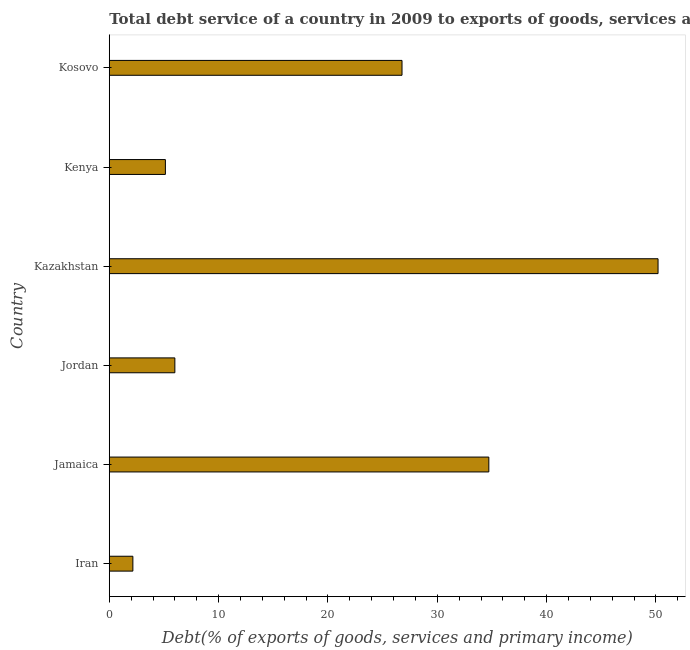Does the graph contain grids?
Offer a terse response. No. What is the title of the graph?
Offer a terse response. Total debt service of a country in 2009 to exports of goods, services and primary income. What is the label or title of the X-axis?
Offer a very short reply. Debt(% of exports of goods, services and primary income). What is the total debt service in Kosovo?
Offer a very short reply. 26.78. Across all countries, what is the maximum total debt service?
Offer a very short reply. 50.19. Across all countries, what is the minimum total debt service?
Your response must be concise. 2.16. In which country was the total debt service maximum?
Offer a very short reply. Kazakhstan. In which country was the total debt service minimum?
Offer a terse response. Iran. What is the sum of the total debt service?
Your response must be concise. 124.98. What is the difference between the total debt service in Kazakhstan and Kenya?
Your answer should be very brief. 45.06. What is the average total debt service per country?
Ensure brevity in your answer.  20.83. What is the median total debt service?
Ensure brevity in your answer.  16.39. What is the ratio of the total debt service in Jordan to that in Kosovo?
Your answer should be compact. 0.22. Is the difference between the total debt service in Jordan and Kosovo greater than the difference between any two countries?
Ensure brevity in your answer.  No. What is the difference between the highest and the second highest total debt service?
Your response must be concise. 15.48. What is the difference between the highest and the lowest total debt service?
Provide a succinct answer. 48.04. How many bars are there?
Your answer should be compact. 6. How many countries are there in the graph?
Ensure brevity in your answer.  6. What is the difference between two consecutive major ticks on the X-axis?
Your response must be concise. 10. Are the values on the major ticks of X-axis written in scientific E-notation?
Make the answer very short. No. What is the Debt(% of exports of goods, services and primary income) in Iran?
Offer a very short reply. 2.16. What is the Debt(% of exports of goods, services and primary income) of Jamaica?
Give a very brief answer. 34.72. What is the Debt(% of exports of goods, services and primary income) of Jordan?
Keep it short and to the point. 6. What is the Debt(% of exports of goods, services and primary income) of Kazakhstan?
Ensure brevity in your answer.  50.19. What is the Debt(% of exports of goods, services and primary income) of Kenya?
Offer a terse response. 5.13. What is the Debt(% of exports of goods, services and primary income) of Kosovo?
Your answer should be very brief. 26.78. What is the difference between the Debt(% of exports of goods, services and primary income) in Iran and Jamaica?
Your answer should be very brief. -32.56. What is the difference between the Debt(% of exports of goods, services and primary income) in Iran and Jordan?
Your answer should be very brief. -3.84. What is the difference between the Debt(% of exports of goods, services and primary income) in Iran and Kazakhstan?
Offer a very short reply. -48.04. What is the difference between the Debt(% of exports of goods, services and primary income) in Iran and Kenya?
Make the answer very short. -2.97. What is the difference between the Debt(% of exports of goods, services and primary income) in Iran and Kosovo?
Offer a very short reply. -24.62. What is the difference between the Debt(% of exports of goods, services and primary income) in Jamaica and Jordan?
Make the answer very short. 28.72. What is the difference between the Debt(% of exports of goods, services and primary income) in Jamaica and Kazakhstan?
Offer a terse response. -15.48. What is the difference between the Debt(% of exports of goods, services and primary income) in Jamaica and Kenya?
Provide a short and direct response. 29.58. What is the difference between the Debt(% of exports of goods, services and primary income) in Jamaica and Kosovo?
Provide a short and direct response. 7.94. What is the difference between the Debt(% of exports of goods, services and primary income) in Jordan and Kazakhstan?
Keep it short and to the point. -44.2. What is the difference between the Debt(% of exports of goods, services and primary income) in Jordan and Kenya?
Give a very brief answer. 0.87. What is the difference between the Debt(% of exports of goods, services and primary income) in Jordan and Kosovo?
Give a very brief answer. -20.78. What is the difference between the Debt(% of exports of goods, services and primary income) in Kazakhstan and Kenya?
Offer a very short reply. 45.06. What is the difference between the Debt(% of exports of goods, services and primary income) in Kazakhstan and Kosovo?
Your response must be concise. 23.42. What is the difference between the Debt(% of exports of goods, services and primary income) in Kenya and Kosovo?
Offer a very short reply. -21.64. What is the ratio of the Debt(% of exports of goods, services and primary income) in Iran to that in Jamaica?
Keep it short and to the point. 0.06. What is the ratio of the Debt(% of exports of goods, services and primary income) in Iran to that in Jordan?
Your response must be concise. 0.36. What is the ratio of the Debt(% of exports of goods, services and primary income) in Iran to that in Kazakhstan?
Provide a succinct answer. 0.04. What is the ratio of the Debt(% of exports of goods, services and primary income) in Iran to that in Kenya?
Your answer should be compact. 0.42. What is the ratio of the Debt(% of exports of goods, services and primary income) in Iran to that in Kosovo?
Your answer should be very brief. 0.08. What is the ratio of the Debt(% of exports of goods, services and primary income) in Jamaica to that in Jordan?
Your answer should be compact. 5.79. What is the ratio of the Debt(% of exports of goods, services and primary income) in Jamaica to that in Kazakhstan?
Provide a succinct answer. 0.69. What is the ratio of the Debt(% of exports of goods, services and primary income) in Jamaica to that in Kenya?
Provide a short and direct response. 6.76. What is the ratio of the Debt(% of exports of goods, services and primary income) in Jamaica to that in Kosovo?
Provide a succinct answer. 1.3. What is the ratio of the Debt(% of exports of goods, services and primary income) in Jordan to that in Kazakhstan?
Your answer should be compact. 0.12. What is the ratio of the Debt(% of exports of goods, services and primary income) in Jordan to that in Kenya?
Your response must be concise. 1.17. What is the ratio of the Debt(% of exports of goods, services and primary income) in Jordan to that in Kosovo?
Ensure brevity in your answer.  0.22. What is the ratio of the Debt(% of exports of goods, services and primary income) in Kazakhstan to that in Kenya?
Keep it short and to the point. 9.78. What is the ratio of the Debt(% of exports of goods, services and primary income) in Kazakhstan to that in Kosovo?
Give a very brief answer. 1.88. What is the ratio of the Debt(% of exports of goods, services and primary income) in Kenya to that in Kosovo?
Your response must be concise. 0.19. 